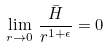Convert formula to latex. <formula><loc_0><loc_0><loc_500><loc_500>\lim _ { r \rightarrow 0 } \, \frac { \bar { H } } { r ^ { 1 + \epsilon } } = 0</formula> 